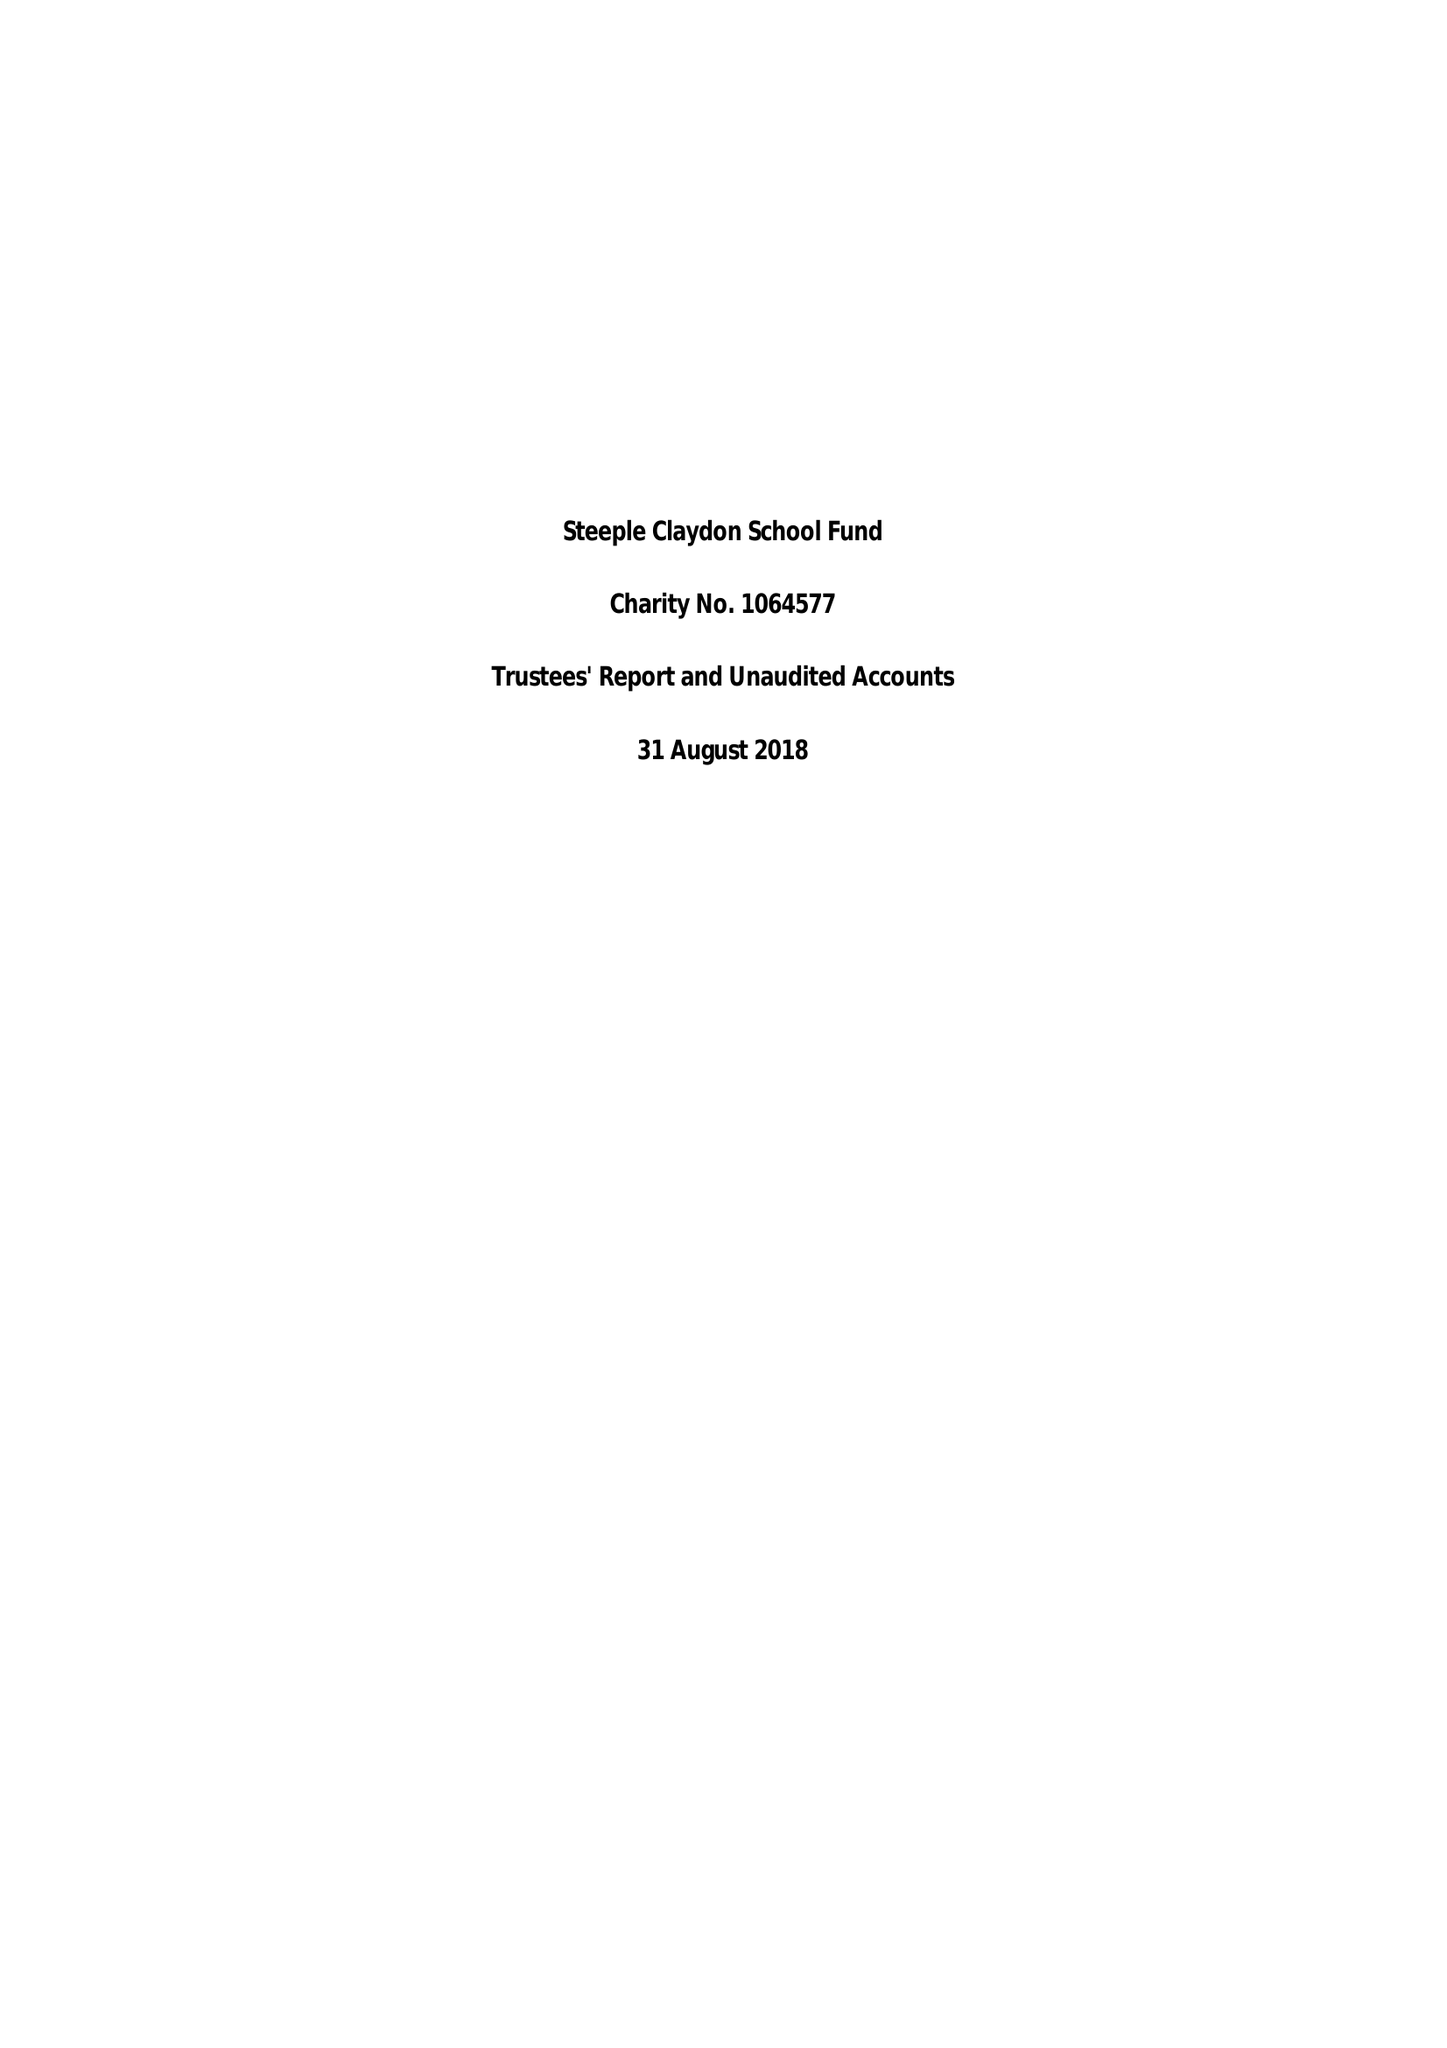What is the value for the charity_number?
Answer the question using a single word or phrase. 1064577 